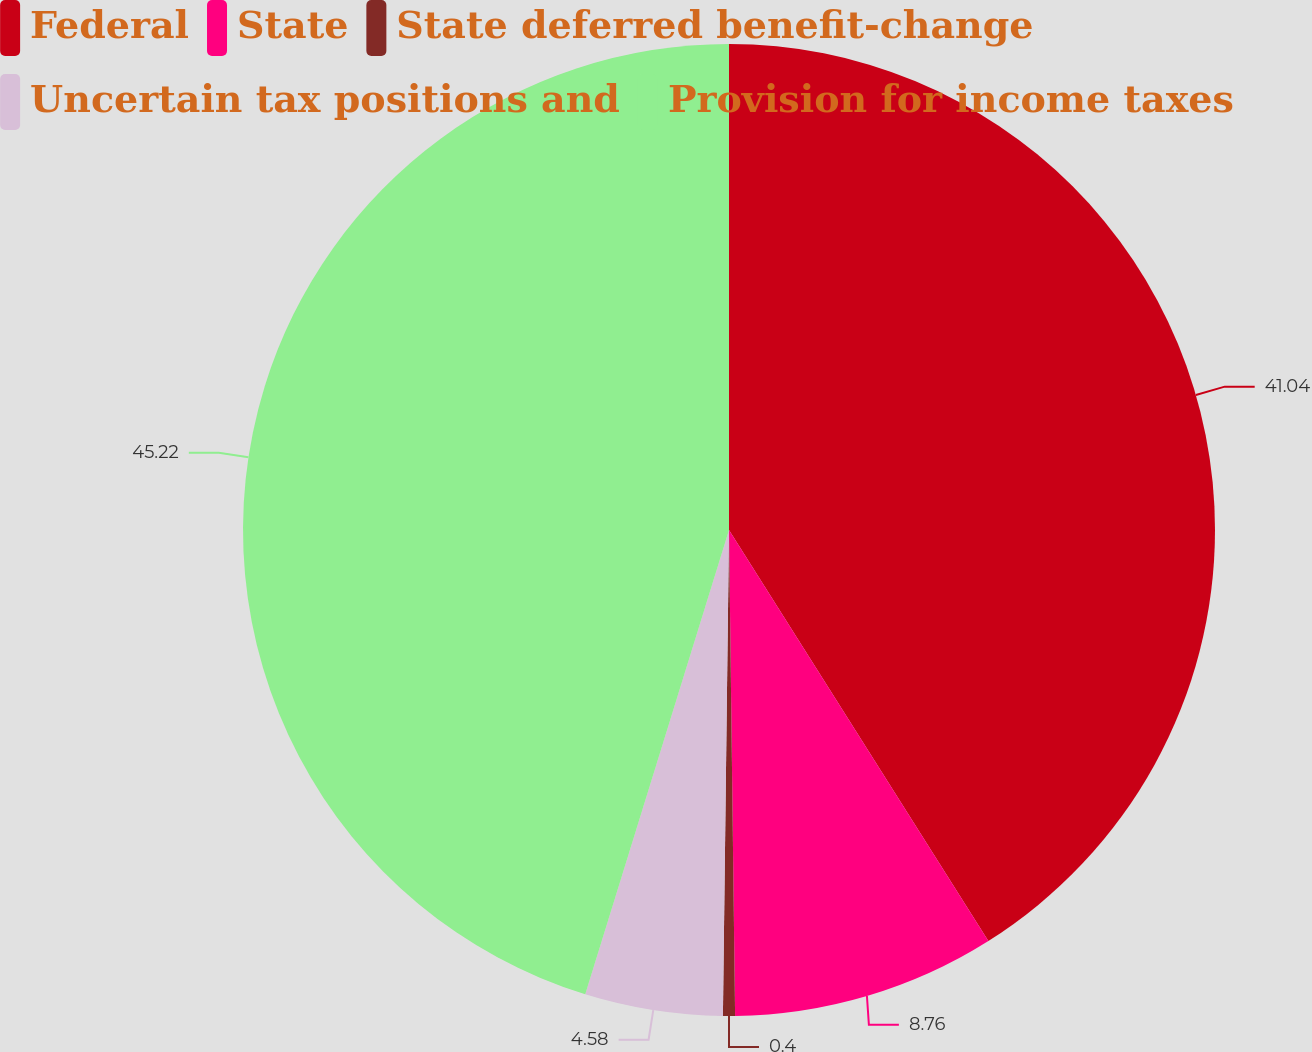Convert chart to OTSL. <chart><loc_0><loc_0><loc_500><loc_500><pie_chart><fcel>Federal<fcel>State<fcel>State deferred benefit-change<fcel>Uncertain tax positions and<fcel>Provision for income taxes<nl><fcel>41.04%<fcel>8.76%<fcel>0.4%<fcel>4.58%<fcel>45.22%<nl></chart> 